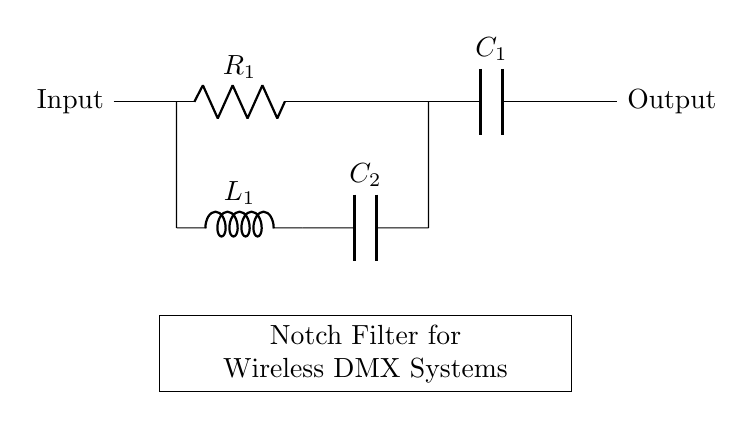What are the components used in this notch filter? The circuit contains a resistor, an inductor, and two capacitors, identified as R1, L1, C1, and C2.
Answer: Resistor, inductor, and capacitors What is the purpose of this circuit? The purpose of the notch filter is to eliminate specific interference frequencies in wireless DMX systems by attenuating unwanted signals.
Answer: Eliminate specific interference frequencies How many capacitors are in the circuit? There are two capacitors present in the diagram, C1 and C2, which serve different roles in the filtering process.
Answer: Two What type of filter is depicted in the circuit? The circuit shown is a notch filter, commonly used to selectively attenuate a narrow band of frequencies while allowing others to pass through.
Answer: Notch filter Which component is responsible for storing energy in the circuit? The inductor (L1) stores energy in its magnetic field when current flows through it, and the capacitors (C1, C2) store energy in an electric field.
Answer: Inductor What distinguishes this filter from other types? A notch filter specifically targets and attenuates a narrow frequency band, while other filters, such as low-pass or high-pass filters, would affect a wider range of frequencies.
Answer: Targets narrow frequency band 